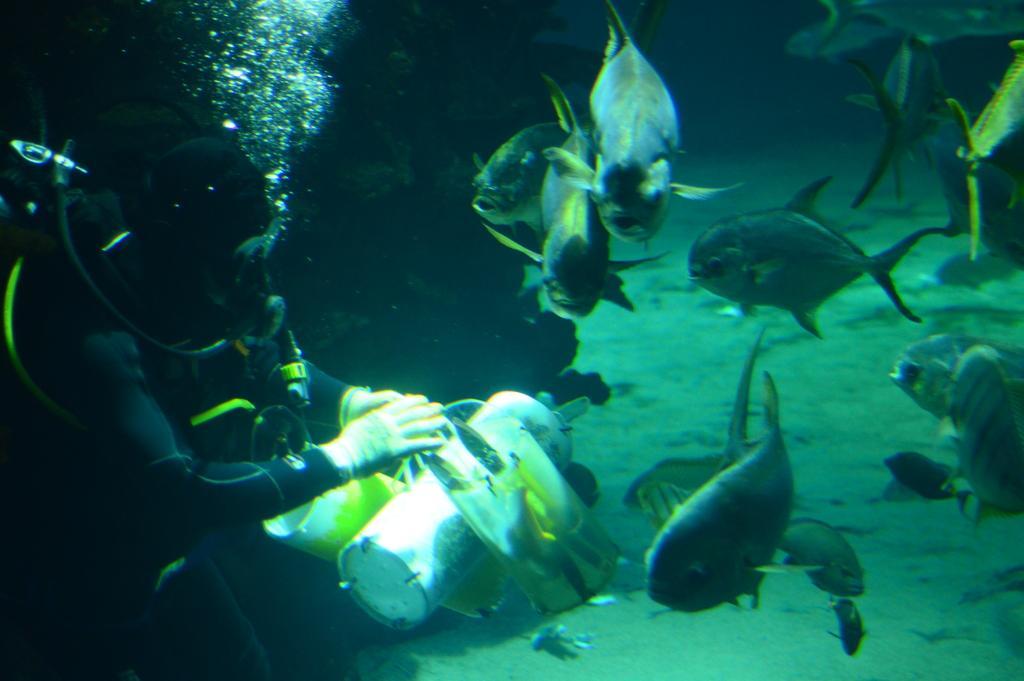In one or two sentences, can you explain what this image depicts? This image is taken in the sea. On the left side of the image there is a man. On the right side of the image there are many fishes in the sea. 